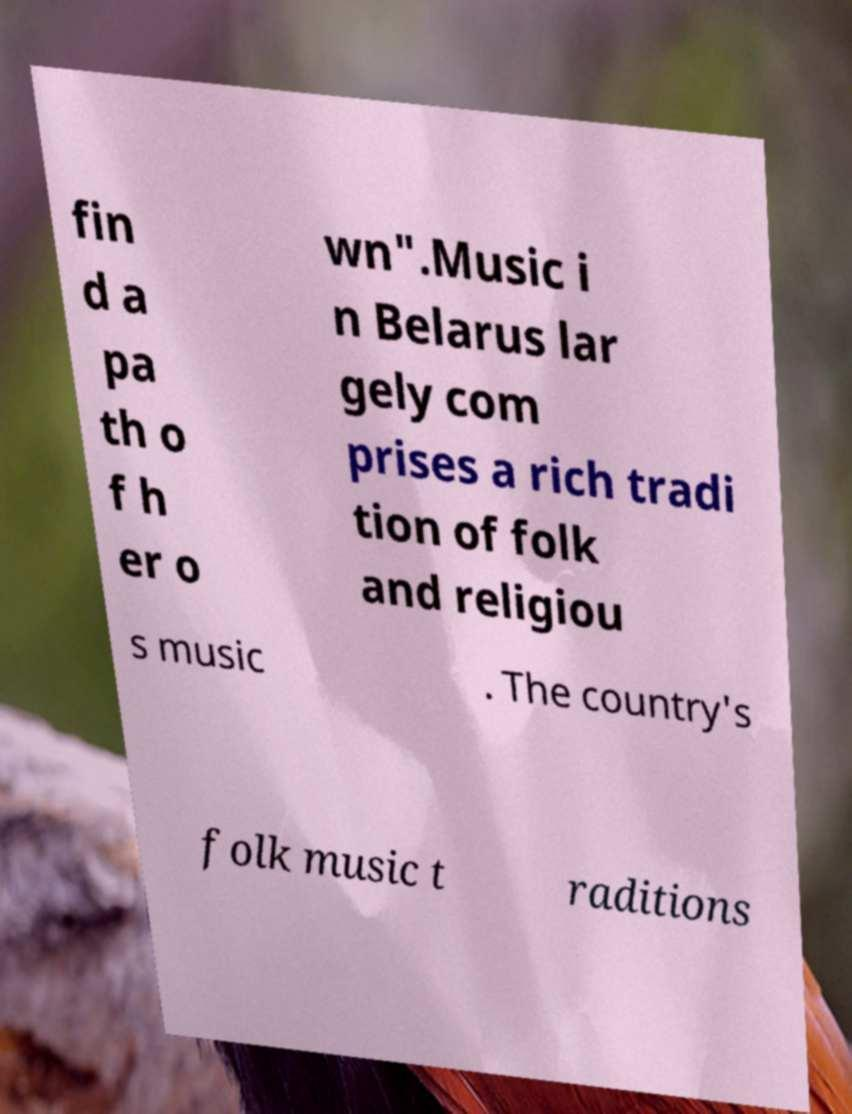Please read and relay the text visible in this image. What does it say? fin d a pa th o f h er o wn".Music i n Belarus lar gely com prises a rich tradi tion of folk and religiou s music . The country's folk music t raditions 